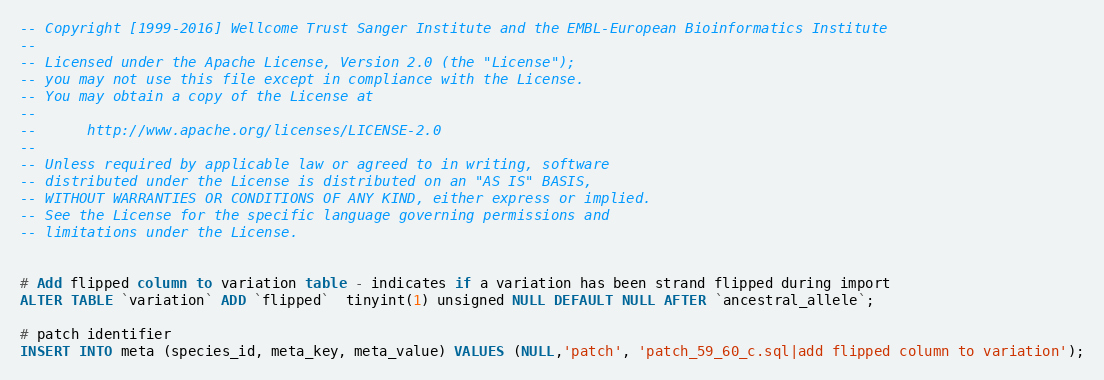<code> <loc_0><loc_0><loc_500><loc_500><_SQL_>-- Copyright [1999-2016] Wellcome Trust Sanger Institute and the EMBL-European Bioinformatics Institute
-- 
-- Licensed under the Apache License, Version 2.0 (the "License");
-- you may not use this file except in compliance with the License.
-- You may obtain a copy of the License at
-- 
--      http://www.apache.org/licenses/LICENSE-2.0
-- 
-- Unless required by applicable law or agreed to in writing, software
-- distributed under the License is distributed on an "AS IS" BASIS,
-- WITHOUT WARRANTIES OR CONDITIONS OF ANY KIND, either express or implied.
-- See the License for the specific language governing permissions and
-- limitations under the License.


# Add flipped column to variation table - indicates if a variation has been strand flipped during import
ALTER TABLE `variation` ADD `flipped`  tinyint(1) unsigned NULL DEFAULT NULL AFTER `ancestral_allele`;

# patch identifier
INSERT INTO meta (species_id, meta_key, meta_value) VALUES (NULL,'patch', 'patch_59_60_c.sql|add flipped column to variation');
</code> 